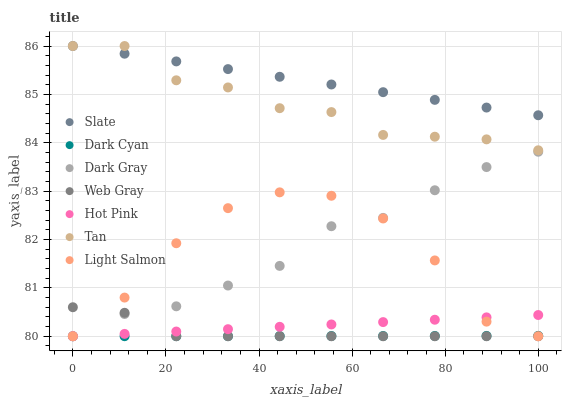Does Dark Cyan have the minimum area under the curve?
Answer yes or no. Yes. Does Slate have the maximum area under the curve?
Answer yes or no. Yes. Does Web Gray have the minimum area under the curve?
Answer yes or no. No. Does Web Gray have the maximum area under the curve?
Answer yes or no. No. Is Dark Cyan the smoothest?
Answer yes or no. Yes. Is Light Salmon the roughest?
Answer yes or no. Yes. Is Web Gray the smoothest?
Answer yes or no. No. Is Web Gray the roughest?
Answer yes or no. No. Does Light Salmon have the lowest value?
Answer yes or no. Yes. Does Slate have the lowest value?
Answer yes or no. No. Does Tan have the highest value?
Answer yes or no. Yes. Does Web Gray have the highest value?
Answer yes or no. No. Is Dark Cyan less than Tan?
Answer yes or no. Yes. Is Tan greater than Web Gray?
Answer yes or no. Yes. Does Light Salmon intersect Dark Gray?
Answer yes or no. Yes. Is Light Salmon less than Dark Gray?
Answer yes or no. No. Is Light Salmon greater than Dark Gray?
Answer yes or no. No. Does Dark Cyan intersect Tan?
Answer yes or no. No. 